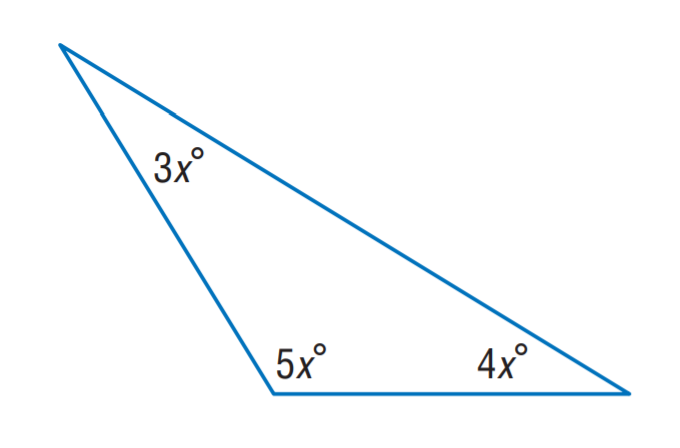Answer the mathemtical geometry problem and directly provide the correct option letter.
Question: Find x.
Choices: A: 5 B: 10 C: 15 D: 20 C 